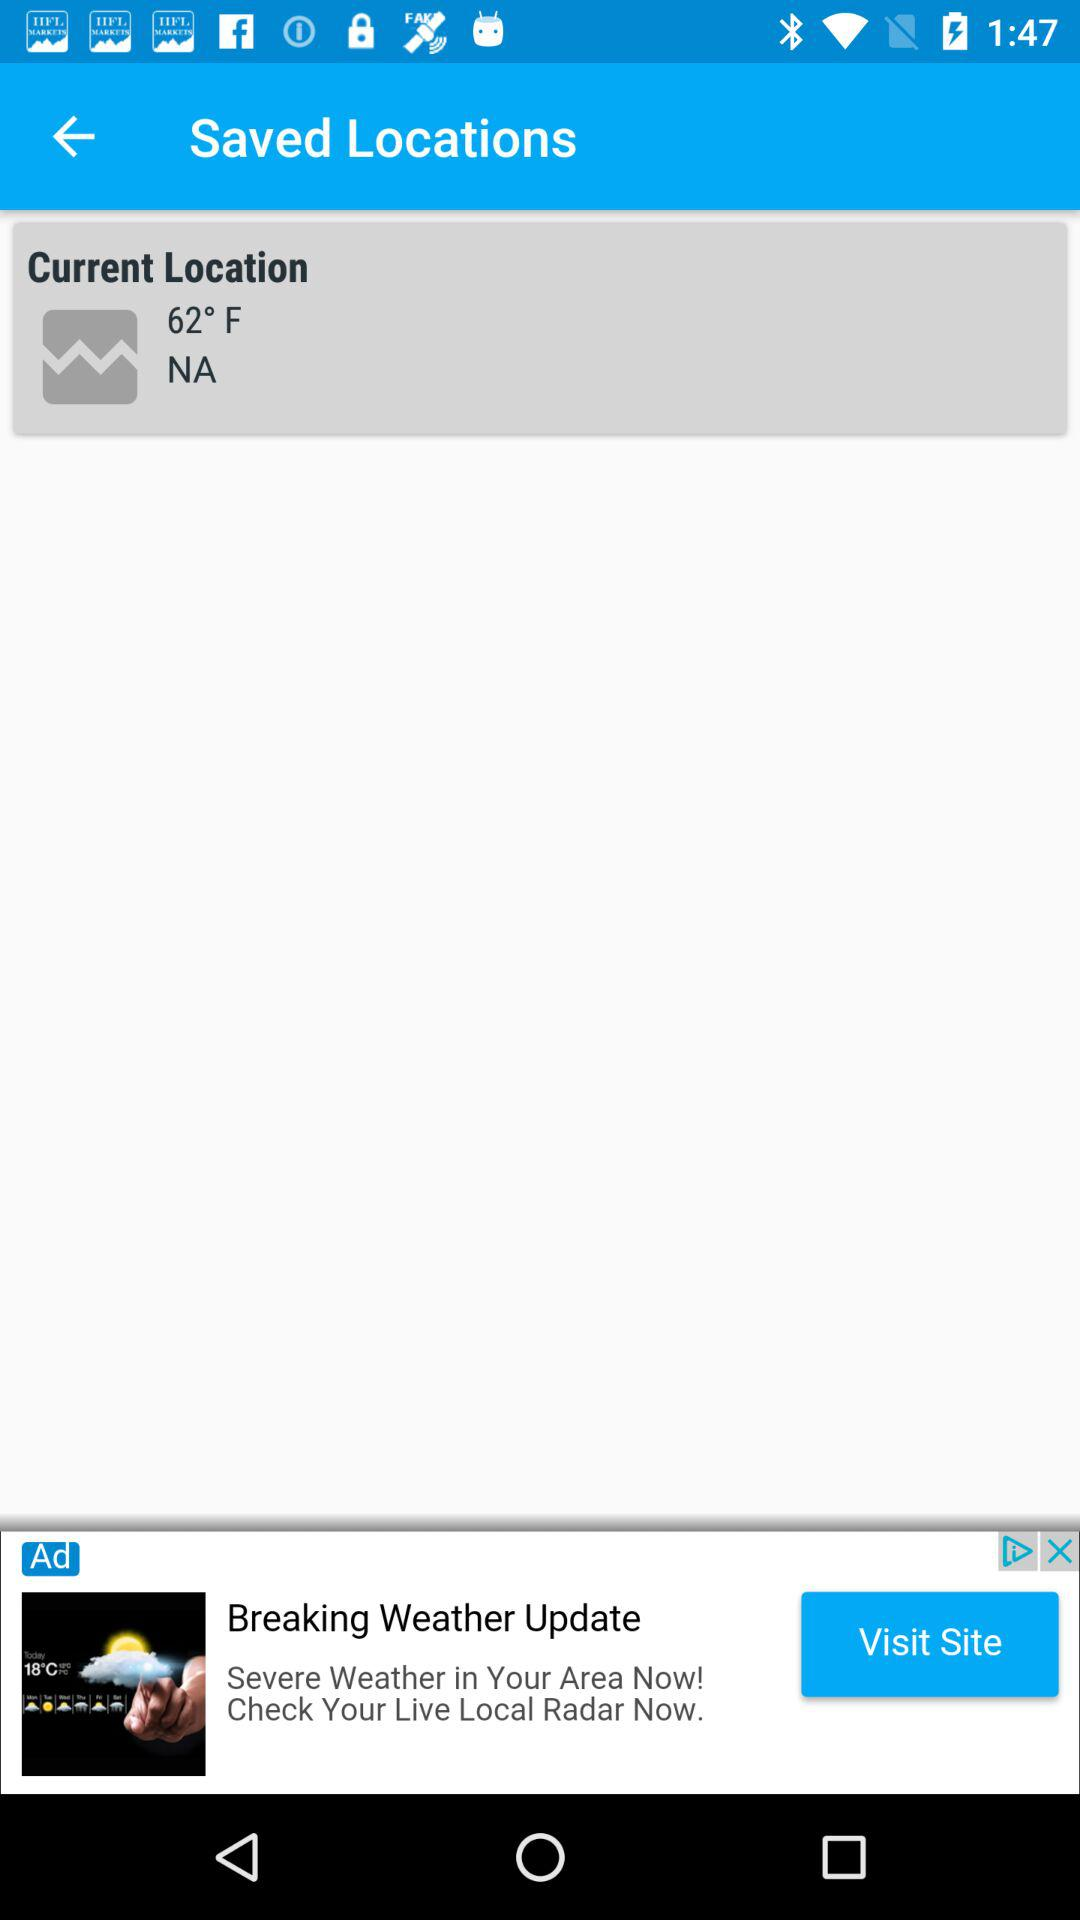What is the temperature at the current location? The temperature is 62 degrees Fahrenheit. 